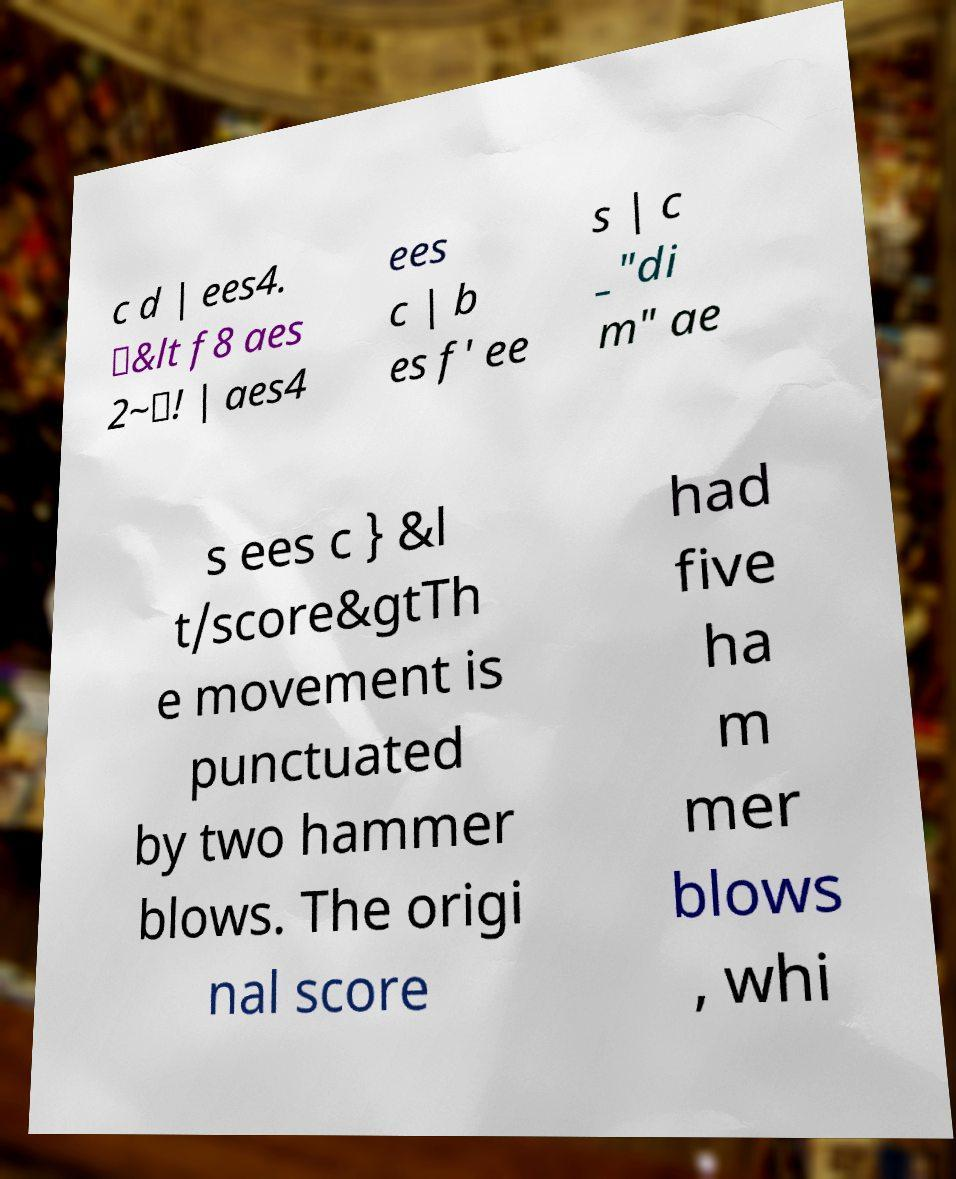Can you read and provide the text displayed in the image?This photo seems to have some interesting text. Can you extract and type it out for me? c d | ees4. \&lt f8 aes 2~\! | aes4 ees c | b es f' ee s | c _"di m" ae s ees c } &l t/score&gtTh e movement is punctuated by two hammer blows. The origi nal score had five ha m mer blows , whi 